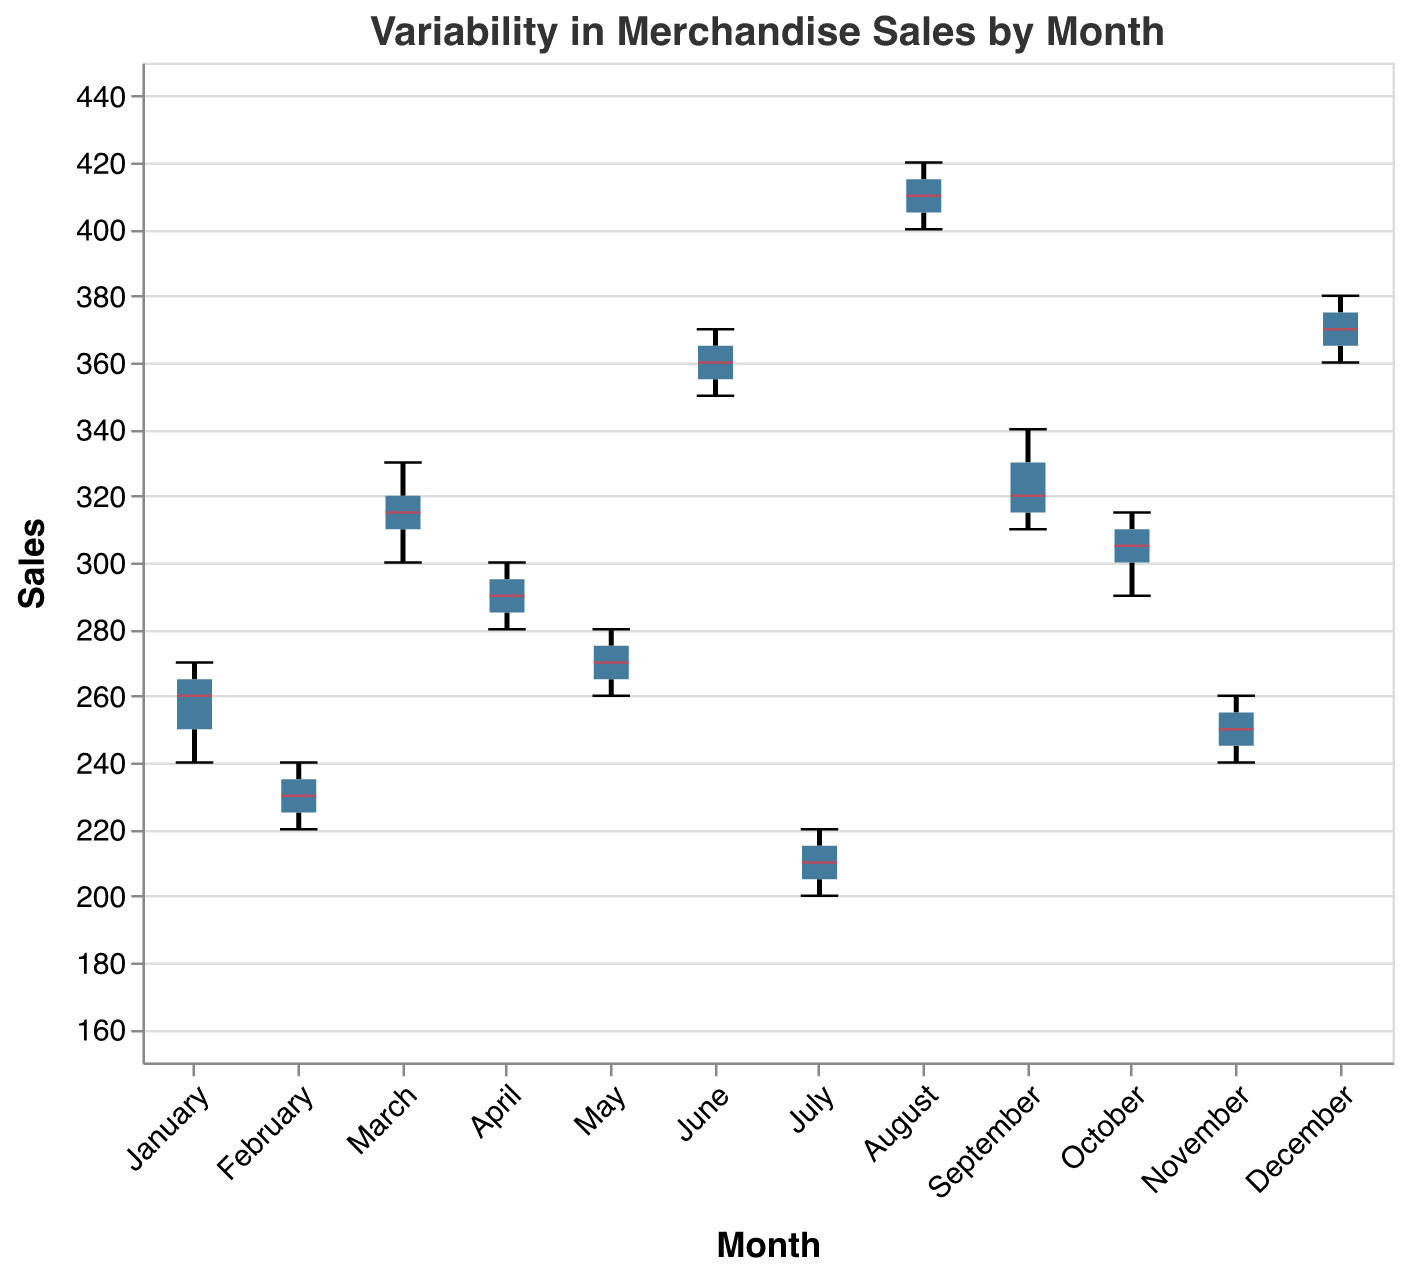What does the title of the plot indicate? The title of the plot is "Variability in Merchandise Sales by Month," which suggests that the plot visualizes how merchandise sales varied across different months over the past year.
Answer: Variability in Merchandise Sales by Month Which month has the highest median sales? Identify the median line inside the box of each month and compare them to find the highest. August has the highest median sales.
Answer: August How does July's sales variability compare to June's? Assess the notches and the spread (whiskers) of the box plot for both months. July's sales have a much narrower range and lower variability compared to June’s sales.
Answer: July < June What is the range of sales in March? The range is found by taking the difference between the maximum and minimum values indicated by the whiskers. For March, the minimum is 300 and the maximum is 330, so the range is 330 - 300 = 30.
Answer: 30 Which month has the smallest range in sales? Identify the month with the smallest distance between the upper and lower whiskers. July has the smallest range in sales.
Answer: July During which month do the sales have the greatest variability? Look for the month with the widest whiskers. August has the greatest variability in sales.
Answer: August What is the median sales value in December? The median sales value is indicated by the horizontal line within the box for December, which is approximately 370.
Answer: 370 Between November and March, which month has higher sales variability? Compare the spread of data (whisker length and box size) between November and March. March has a higher sales variability compared to November.
Answer: March What is the lower quartile (Q1) value for April? The lower quartile (Q1) is the bottom line of the box. For April, the Q1 value is approximately 285.
Answer: 285 How do the medians of June and December compare? Identify the positions of the median lines within the boxes for both June and December. The medians for both months are exactly the same at approximately 365-370.
Answer: Equal 